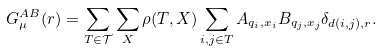<formula> <loc_0><loc_0><loc_500><loc_500>G ^ { A B } _ { \mu } ( r ) = \sum _ { T \in \mathcal { T } } \sum _ { X } \rho ( T , X ) \sum _ { i , j \in T } A _ { q _ { i } , x _ { i } } B _ { q _ { j } , x _ { j } } \delta _ { d ( i , j ) , r } .</formula> 